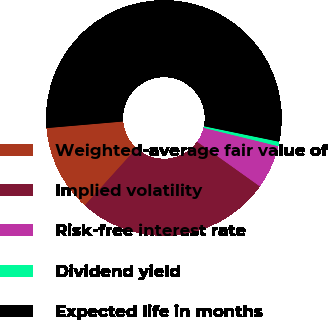Convert chart to OTSL. <chart><loc_0><loc_0><loc_500><loc_500><pie_chart><fcel>Weighted-average fair value of<fcel>Implied volatility<fcel>Risk-free interest rate<fcel>Dividend yield<fcel>Expected life in months<nl><fcel>11.93%<fcel>26.85%<fcel>6.01%<fcel>0.61%<fcel>54.6%<nl></chart> 